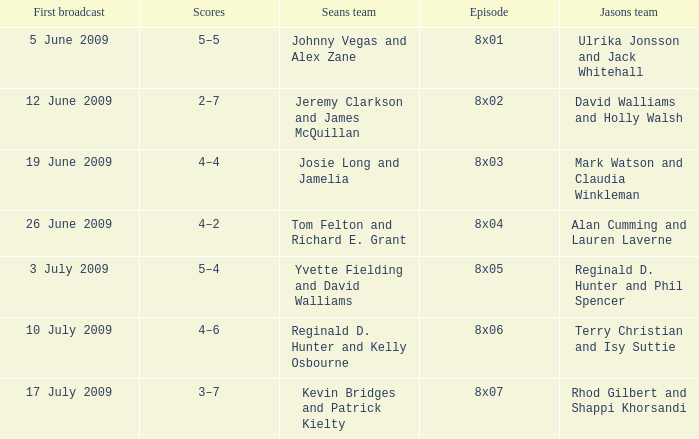Who was on Jason's team in the episode where Sean's team was Reginald D. Hunter and Kelly Osbourne? Terry Christian and Isy Suttie. 